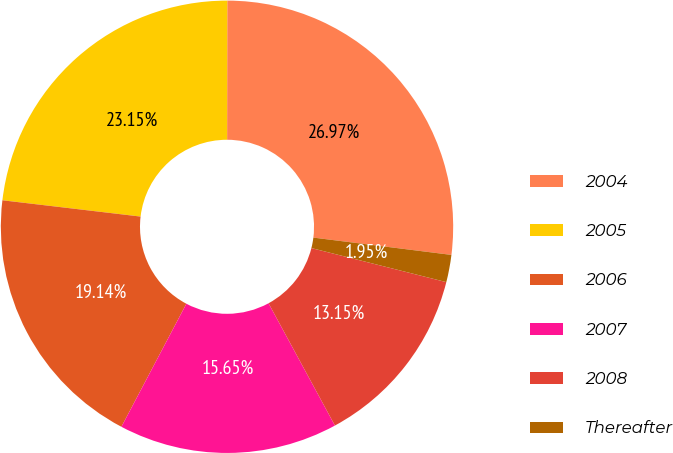Convert chart. <chart><loc_0><loc_0><loc_500><loc_500><pie_chart><fcel>2004<fcel>2005<fcel>2006<fcel>2007<fcel>2008<fcel>Thereafter<nl><fcel>26.97%<fcel>23.15%<fcel>19.14%<fcel>15.65%<fcel>13.15%<fcel>1.95%<nl></chart> 